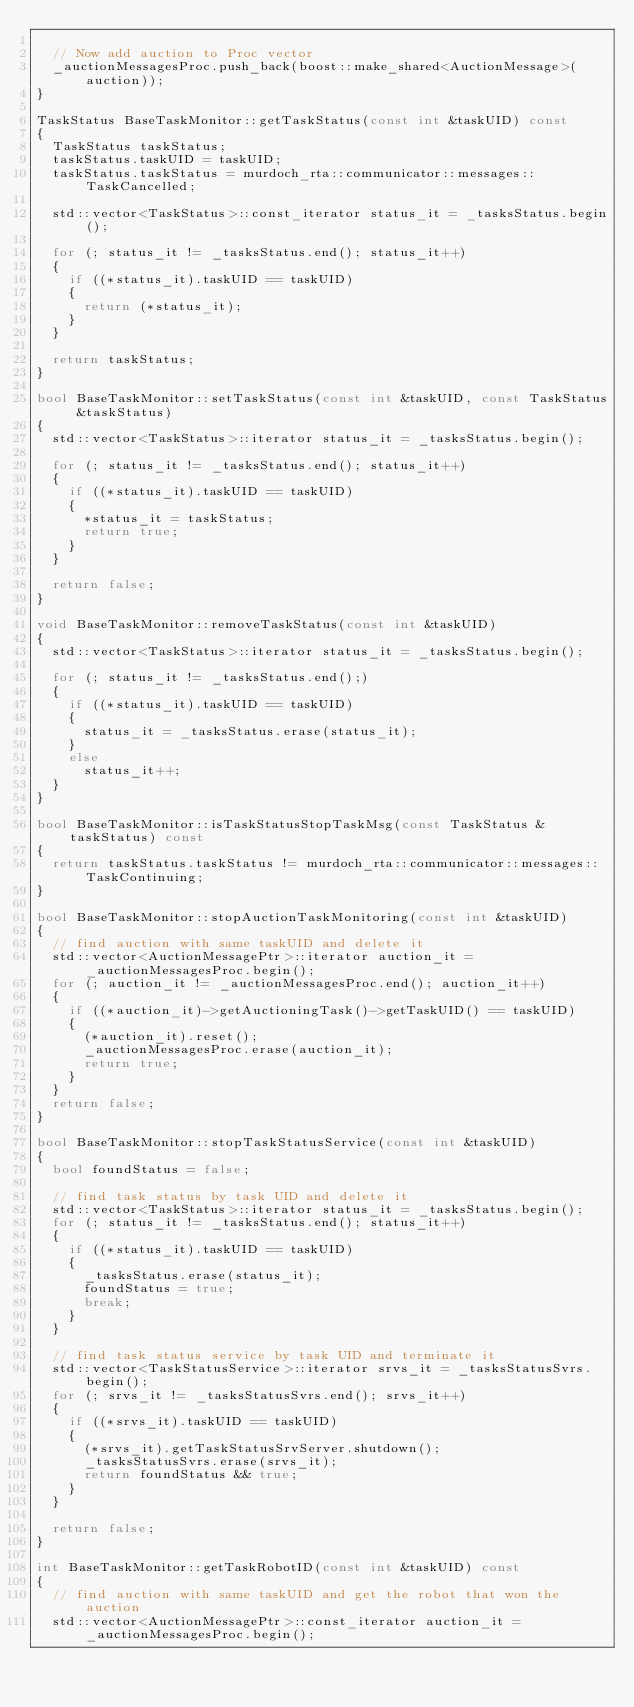<code> <loc_0><loc_0><loc_500><loc_500><_C++_>
  // Now add auction to Proc vector
  _auctionMessagesProc.push_back(boost::make_shared<AuctionMessage>(auction));
}

TaskStatus BaseTaskMonitor::getTaskStatus(const int &taskUID) const
{
  TaskStatus taskStatus;
  taskStatus.taskUID = taskUID;
  taskStatus.taskStatus = murdoch_rta::communicator::messages::TaskCancelled;

  std::vector<TaskStatus>::const_iterator status_it = _tasksStatus.begin();

  for (; status_it != _tasksStatus.end(); status_it++)
  {
    if ((*status_it).taskUID == taskUID)
    {
      return (*status_it);
    }
  }

  return taskStatus;
}

bool BaseTaskMonitor::setTaskStatus(const int &taskUID, const TaskStatus &taskStatus)
{
  std::vector<TaskStatus>::iterator status_it = _tasksStatus.begin();

  for (; status_it != _tasksStatus.end(); status_it++)
  {
    if ((*status_it).taskUID == taskUID)
    {
      *status_it = taskStatus;
      return true;
    }
  }

  return false;
}

void BaseTaskMonitor::removeTaskStatus(const int &taskUID)
{
  std::vector<TaskStatus>::iterator status_it = _tasksStatus.begin();

  for (; status_it != _tasksStatus.end();)
  {
    if ((*status_it).taskUID == taskUID)
    {
      status_it = _tasksStatus.erase(status_it);
    }
    else
      status_it++;
  }
}

bool BaseTaskMonitor::isTaskStatusStopTaskMsg(const TaskStatus &taskStatus) const
{
  return taskStatus.taskStatus != murdoch_rta::communicator::messages::TaskContinuing;
}

bool BaseTaskMonitor::stopAuctionTaskMonitoring(const int &taskUID)
{
  // find auction with same taskUID and delete it
  std::vector<AuctionMessagePtr>::iterator auction_it = _auctionMessagesProc.begin();
  for (; auction_it != _auctionMessagesProc.end(); auction_it++)
  {
    if ((*auction_it)->getAuctioningTask()->getTaskUID() == taskUID)
    {
      (*auction_it).reset();
      _auctionMessagesProc.erase(auction_it);
      return true;
    }
  }
  return false;
}

bool BaseTaskMonitor::stopTaskStatusService(const int &taskUID)
{
  bool foundStatus = false;

  // find task status by task UID and delete it
  std::vector<TaskStatus>::iterator status_it = _tasksStatus.begin();
  for (; status_it != _tasksStatus.end(); status_it++)
  {
    if ((*status_it).taskUID == taskUID)
    {
      _tasksStatus.erase(status_it);
      foundStatus = true;
      break;
    }
  }

  // find task status service by task UID and terminate it
  std::vector<TaskStatusService>::iterator srvs_it = _tasksStatusSvrs.begin();
  for (; srvs_it != _tasksStatusSvrs.end(); srvs_it++)
  {
    if ((*srvs_it).taskUID == taskUID)
    {
      (*srvs_it).getTaskStatusSrvServer.shutdown();
      _tasksStatusSvrs.erase(srvs_it);
      return foundStatus && true;
    }
  }

  return false;
}

int BaseTaskMonitor::getTaskRobotID(const int &taskUID) const
{
  // find auction with same taskUID and get the robot that won the auction
  std::vector<AuctionMessagePtr>::const_iterator auction_it = _auctionMessagesProc.begin();
</code> 